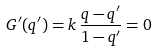Convert formula to latex. <formula><loc_0><loc_0><loc_500><loc_500>G ^ { \prime } ( q ^ { \prime } ) = k \, \frac { q - q ^ { \prime } } { 1 - q ^ { \prime } } = 0</formula> 